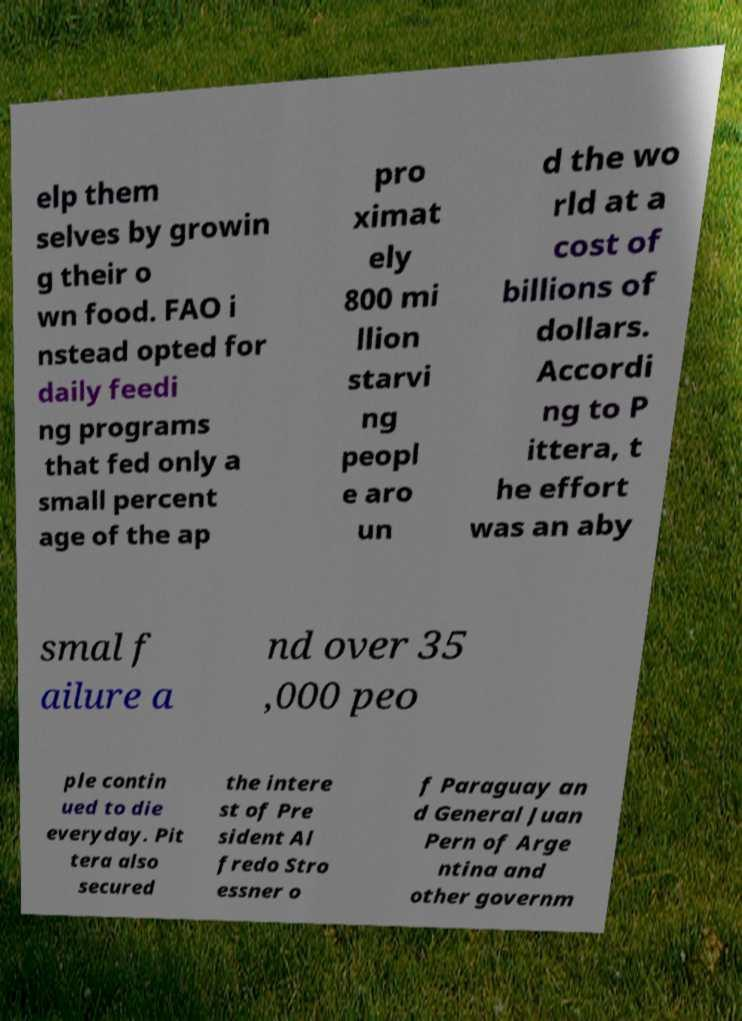Please identify and transcribe the text found in this image. elp them selves by growin g their o wn food. FAO i nstead opted for daily feedi ng programs that fed only a small percent age of the ap pro ximat ely 800 mi llion starvi ng peopl e aro un d the wo rld at a cost of billions of dollars. Accordi ng to P ittera, t he effort was an aby smal f ailure a nd over 35 ,000 peo ple contin ued to die everyday. Pit tera also secured the intere st of Pre sident Al fredo Stro essner o f Paraguay an d General Juan Pern of Arge ntina and other governm 